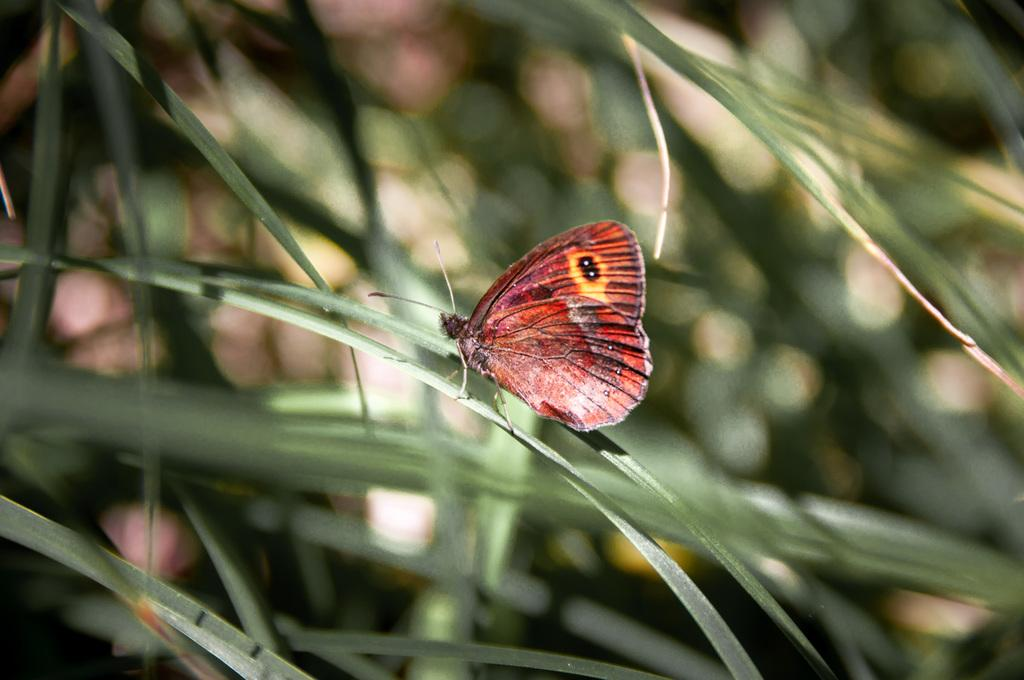What type of living organisms can be seen in the image? Plants are visible in the image. What is on the plant in the image? There is a butterfly on a plant in the image. Can you describe the background of the image? The background of the image is blurred. What type of tray can be seen holding the discovery in the image? There is no tray or discovery present in the image; it features plants and a butterfly. What type of horn is visible on the butterfly in the image? Butterflies do not have horns, and there is no horn visible in the image. 